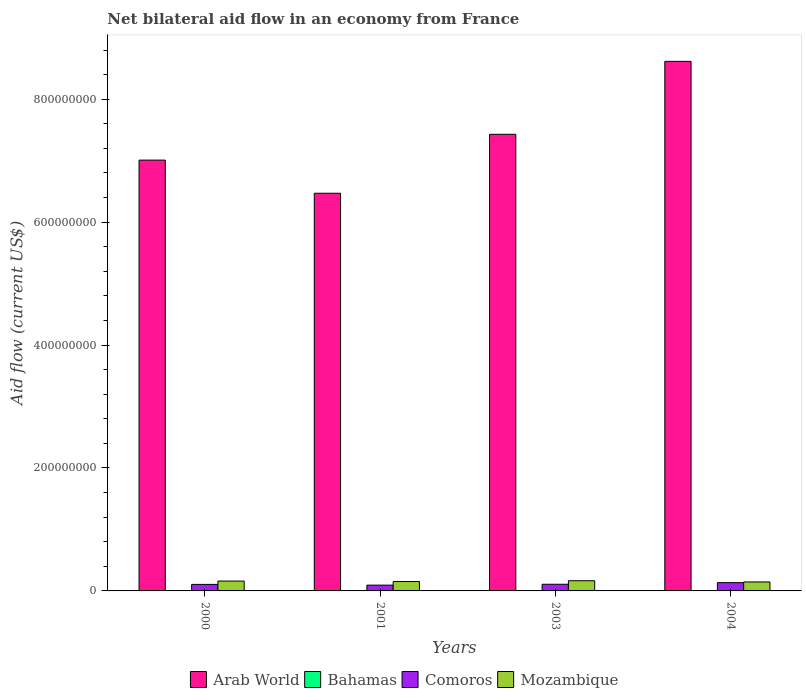How many different coloured bars are there?
Ensure brevity in your answer.  4. How many groups of bars are there?
Make the answer very short. 4. Are the number of bars per tick equal to the number of legend labels?
Offer a very short reply. Yes. Are the number of bars on each tick of the X-axis equal?
Provide a succinct answer. Yes. What is the label of the 2nd group of bars from the left?
Make the answer very short. 2001. What is the net bilateral aid flow in Mozambique in 2003?
Your response must be concise. 1.66e+07. Across all years, what is the maximum net bilateral aid flow in Mozambique?
Ensure brevity in your answer.  1.66e+07. Across all years, what is the minimum net bilateral aid flow in Bahamas?
Give a very brief answer. 10000. In which year was the net bilateral aid flow in Arab World maximum?
Ensure brevity in your answer.  2004. In which year was the net bilateral aid flow in Bahamas minimum?
Provide a succinct answer. 2000. What is the total net bilateral aid flow in Arab World in the graph?
Keep it short and to the point. 2.95e+09. What is the difference between the net bilateral aid flow in Bahamas in 2000 and the net bilateral aid flow in Comoros in 2003?
Your response must be concise. -1.08e+07. What is the average net bilateral aid flow in Bahamas per year?
Make the answer very short. 10000. In the year 2001, what is the difference between the net bilateral aid flow in Arab World and net bilateral aid flow in Mozambique?
Keep it short and to the point. 6.32e+08. What is the ratio of the net bilateral aid flow in Mozambique in 2001 to that in 2003?
Offer a very short reply. 0.92. Is the net bilateral aid flow in Arab World in 2000 less than that in 2004?
Provide a succinct answer. Yes. Is the difference between the net bilateral aid flow in Arab World in 2000 and 2001 greater than the difference between the net bilateral aid flow in Mozambique in 2000 and 2001?
Offer a terse response. Yes. What is the difference between the highest and the second highest net bilateral aid flow in Comoros?
Keep it short and to the point. 2.66e+06. In how many years, is the net bilateral aid flow in Mozambique greater than the average net bilateral aid flow in Mozambique taken over all years?
Your response must be concise. 2. Is the sum of the net bilateral aid flow in Mozambique in 2001 and 2003 greater than the maximum net bilateral aid flow in Comoros across all years?
Your answer should be compact. Yes. Is it the case that in every year, the sum of the net bilateral aid flow in Arab World and net bilateral aid flow in Mozambique is greater than the sum of net bilateral aid flow in Comoros and net bilateral aid flow in Bahamas?
Ensure brevity in your answer.  Yes. What does the 2nd bar from the left in 2001 represents?
Your response must be concise. Bahamas. What does the 1st bar from the right in 2004 represents?
Make the answer very short. Mozambique. How many bars are there?
Your answer should be compact. 16. How many years are there in the graph?
Your response must be concise. 4. What is the difference between two consecutive major ticks on the Y-axis?
Give a very brief answer. 2.00e+08. Are the values on the major ticks of Y-axis written in scientific E-notation?
Ensure brevity in your answer.  No. Does the graph contain any zero values?
Make the answer very short. No. How are the legend labels stacked?
Offer a very short reply. Horizontal. What is the title of the graph?
Keep it short and to the point. Net bilateral aid flow in an economy from France. What is the label or title of the X-axis?
Give a very brief answer. Years. What is the Aid flow (current US$) of Arab World in 2000?
Provide a succinct answer. 7.01e+08. What is the Aid flow (current US$) of Bahamas in 2000?
Your response must be concise. 10000. What is the Aid flow (current US$) in Comoros in 2000?
Provide a succinct answer. 1.06e+07. What is the Aid flow (current US$) in Mozambique in 2000?
Provide a short and direct response. 1.60e+07. What is the Aid flow (current US$) in Arab World in 2001?
Offer a very short reply. 6.47e+08. What is the Aid flow (current US$) in Comoros in 2001?
Give a very brief answer. 9.42e+06. What is the Aid flow (current US$) of Mozambique in 2001?
Offer a very short reply. 1.53e+07. What is the Aid flow (current US$) of Arab World in 2003?
Provide a succinct answer. 7.43e+08. What is the Aid flow (current US$) of Bahamas in 2003?
Offer a very short reply. 10000. What is the Aid flow (current US$) in Comoros in 2003?
Offer a very short reply. 1.08e+07. What is the Aid flow (current US$) of Mozambique in 2003?
Ensure brevity in your answer.  1.66e+07. What is the Aid flow (current US$) of Arab World in 2004?
Your answer should be very brief. 8.62e+08. What is the Aid flow (current US$) of Comoros in 2004?
Your answer should be very brief. 1.35e+07. What is the Aid flow (current US$) of Mozambique in 2004?
Provide a succinct answer. 1.46e+07. Across all years, what is the maximum Aid flow (current US$) of Arab World?
Provide a succinct answer. 8.62e+08. Across all years, what is the maximum Aid flow (current US$) of Comoros?
Your answer should be compact. 1.35e+07. Across all years, what is the maximum Aid flow (current US$) in Mozambique?
Offer a very short reply. 1.66e+07. Across all years, what is the minimum Aid flow (current US$) in Arab World?
Keep it short and to the point. 6.47e+08. Across all years, what is the minimum Aid flow (current US$) of Bahamas?
Your answer should be compact. 10000. Across all years, what is the minimum Aid flow (current US$) in Comoros?
Offer a very short reply. 9.42e+06. Across all years, what is the minimum Aid flow (current US$) of Mozambique?
Your response must be concise. 1.46e+07. What is the total Aid flow (current US$) of Arab World in the graph?
Your response must be concise. 2.95e+09. What is the total Aid flow (current US$) in Comoros in the graph?
Your response must be concise. 4.43e+07. What is the total Aid flow (current US$) in Mozambique in the graph?
Ensure brevity in your answer.  6.26e+07. What is the difference between the Aid flow (current US$) in Arab World in 2000 and that in 2001?
Make the answer very short. 5.39e+07. What is the difference between the Aid flow (current US$) of Comoros in 2000 and that in 2001?
Your response must be concise. 1.18e+06. What is the difference between the Aid flow (current US$) of Mozambique in 2000 and that in 2001?
Ensure brevity in your answer.  7.40e+05. What is the difference between the Aid flow (current US$) of Arab World in 2000 and that in 2003?
Keep it short and to the point. -4.20e+07. What is the difference between the Aid flow (current US$) in Comoros in 2000 and that in 2003?
Give a very brief answer. -2.30e+05. What is the difference between the Aid flow (current US$) of Mozambique in 2000 and that in 2003?
Offer a terse response. -5.40e+05. What is the difference between the Aid flow (current US$) in Arab World in 2000 and that in 2004?
Keep it short and to the point. -1.61e+08. What is the difference between the Aid flow (current US$) of Bahamas in 2000 and that in 2004?
Provide a succinct answer. 0. What is the difference between the Aid flow (current US$) in Comoros in 2000 and that in 2004?
Ensure brevity in your answer.  -2.89e+06. What is the difference between the Aid flow (current US$) in Mozambique in 2000 and that in 2004?
Offer a terse response. 1.44e+06. What is the difference between the Aid flow (current US$) of Arab World in 2001 and that in 2003?
Make the answer very short. -9.59e+07. What is the difference between the Aid flow (current US$) of Bahamas in 2001 and that in 2003?
Make the answer very short. 0. What is the difference between the Aid flow (current US$) in Comoros in 2001 and that in 2003?
Keep it short and to the point. -1.41e+06. What is the difference between the Aid flow (current US$) in Mozambique in 2001 and that in 2003?
Ensure brevity in your answer.  -1.28e+06. What is the difference between the Aid flow (current US$) in Arab World in 2001 and that in 2004?
Offer a terse response. -2.15e+08. What is the difference between the Aid flow (current US$) in Comoros in 2001 and that in 2004?
Your response must be concise. -4.07e+06. What is the difference between the Aid flow (current US$) of Mozambique in 2001 and that in 2004?
Provide a succinct answer. 7.00e+05. What is the difference between the Aid flow (current US$) of Arab World in 2003 and that in 2004?
Provide a succinct answer. -1.19e+08. What is the difference between the Aid flow (current US$) of Comoros in 2003 and that in 2004?
Offer a very short reply. -2.66e+06. What is the difference between the Aid flow (current US$) of Mozambique in 2003 and that in 2004?
Offer a terse response. 1.98e+06. What is the difference between the Aid flow (current US$) in Arab World in 2000 and the Aid flow (current US$) in Bahamas in 2001?
Your response must be concise. 7.01e+08. What is the difference between the Aid flow (current US$) of Arab World in 2000 and the Aid flow (current US$) of Comoros in 2001?
Keep it short and to the point. 6.91e+08. What is the difference between the Aid flow (current US$) in Arab World in 2000 and the Aid flow (current US$) in Mozambique in 2001?
Keep it short and to the point. 6.86e+08. What is the difference between the Aid flow (current US$) of Bahamas in 2000 and the Aid flow (current US$) of Comoros in 2001?
Offer a very short reply. -9.41e+06. What is the difference between the Aid flow (current US$) in Bahamas in 2000 and the Aid flow (current US$) in Mozambique in 2001?
Offer a terse response. -1.53e+07. What is the difference between the Aid flow (current US$) of Comoros in 2000 and the Aid flow (current US$) of Mozambique in 2001?
Give a very brief answer. -4.71e+06. What is the difference between the Aid flow (current US$) of Arab World in 2000 and the Aid flow (current US$) of Bahamas in 2003?
Your response must be concise. 7.01e+08. What is the difference between the Aid flow (current US$) in Arab World in 2000 and the Aid flow (current US$) in Comoros in 2003?
Offer a terse response. 6.90e+08. What is the difference between the Aid flow (current US$) in Arab World in 2000 and the Aid flow (current US$) in Mozambique in 2003?
Your answer should be very brief. 6.84e+08. What is the difference between the Aid flow (current US$) of Bahamas in 2000 and the Aid flow (current US$) of Comoros in 2003?
Make the answer very short. -1.08e+07. What is the difference between the Aid flow (current US$) in Bahamas in 2000 and the Aid flow (current US$) in Mozambique in 2003?
Your answer should be compact. -1.66e+07. What is the difference between the Aid flow (current US$) in Comoros in 2000 and the Aid flow (current US$) in Mozambique in 2003?
Your answer should be compact. -5.99e+06. What is the difference between the Aid flow (current US$) in Arab World in 2000 and the Aid flow (current US$) in Bahamas in 2004?
Keep it short and to the point. 7.01e+08. What is the difference between the Aid flow (current US$) in Arab World in 2000 and the Aid flow (current US$) in Comoros in 2004?
Give a very brief answer. 6.87e+08. What is the difference between the Aid flow (current US$) in Arab World in 2000 and the Aid flow (current US$) in Mozambique in 2004?
Ensure brevity in your answer.  6.86e+08. What is the difference between the Aid flow (current US$) in Bahamas in 2000 and the Aid flow (current US$) in Comoros in 2004?
Your answer should be compact. -1.35e+07. What is the difference between the Aid flow (current US$) in Bahamas in 2000 and the Aid flow (current US$) in Mozambique in 2004?
Provide a succinct answer. -1.46e+07. What is the difference between the Aid flow (current US$) of Comoros in 2000 and the Aid flow (current US$) of Mozambique in 2004?
Your answer should be compact. -4.01e+06. What is the difference between the Aid flow (current US$) in Arab World in 2001 and the Aid flow (current US$) in Bahamas in 2003?
Your answer should be compact. 6.47e+08. What is the difference between the Aid flow (current US$) of Arab World in 2001 and the Aid flow (current US$) of Comoros in 2003?
Offer a terse response. 6.36e+08. What is the difference between the Aid flow (current US$) in Arab World in 2001 and the Aid flow (current US$) in Mozambique in 2003?
Provide a short and direct response. 6.30e+08. What is the difference between the Aid flow (current US$) in Bahamas in 2001 and the Aid flow (current US$) in Comoros in 2003?
Ensure brevity in your answer.  -1.08e+07. What is the difference between the Aid flow (current US$) in Bahamas in 2001 and the Aid flow (current US$) in Mozambique in 2003?
Give a very brief answer. -1.66e+07. What is the difference between the Aid flow (current US$) in Comoros in 2001 and the Aid flow (current US$) in Mozambique in 2003?
Your response must be concise. -7.17e+06. What is the difference between the Aid flow (current US$) of Arab World in 2001 and the Aid flow (current US$) of Bahamas in 2004?
Give a very brief answer. 6.47e+08. What is the difference between the Aid flow (current US$) of Arab World in 2001 and the Aid flow (current US$) of Comoros in 2004?
Offer a very short reply. 6.34e+08. What is the difference between the Aid flow (current US$) of Arab World in 2001 and the Aid flow (current US$) of Mozambique in 2004?
Make the answer very short. 6.32e+08. What is the difference between the Aid flow (current US$) of Bahamas in 2001 and the Aid flow (current US$) of Comoros in 2004?
Your answer should be very brief. -1.35e+07. What is the difference between the Aid flow (current US$) of Bahamas in 2001 and the Aid flow (current US$) of Mozambique in 2004?
Provide a short and direct response. -1.46e+07. What is the difference between the Aid flow (current US$) of Comoros in 2001 and the Aid flow (current US$) of Mozambique in 2004?
Keep it short and to the point. -5.19e+06. What is the difference between the Aid flow (current US$) in Arab World in 2003 and the Aid flow (current US$) in Bahamas in 2004?
Give a very brief answer. 7.43e+08. What is the difference between the Aid flow (current US$) of Arab World in 2003 and the Aid flow (current US$) of Comoros in 2004?
Provide a short and direct response. 7.29e+08. What is the difference between the Aid flow (current US$) in Arab World in 2003 and the Aid flow (current US$) in Mozambique in 2004?
Provide a short and direct response. 7.28e+08. What is the difference between the Aid flow (current US$) in Bahamas in 2003 and the Aid flow (current US$) in Comoros in 2004?
Offer a very short reply. -1.35e+07. What is the difference between the Aid flow (current US$) in Bahamas in 2003 and the Aid flow (current US$) in Mozambique in 2004?
Keep it short and to the point. -1.46e+07. What is the difference between the Aid flow (current US$) of Comoros in 2003 and the Aid flow (current US$) of Mozambique in 2004?
Your answer should be compact. -3.78e+06. What is the average Aid flow (current US$) in Arab World per year?
Provide a succinct answer. 7.38e+08. What is the average Aid flow (current US$) of Comoros per year?
Offer a very short reply. 1.11e+07. What is the average Aid flow (current US$) of Mozambique per year?
Your answer should be very brief. 1.56e+07. In the year 2000, what is the difference between the Aid flow (current US$) of Arab World and Aid flow (current US$) of Bahamas?
Provide a succinct answer. 7.01e+08. In the year 2000, what is the difference between the Aid flow (current US$) of Arab World and Aid flow (current US$) of Comoros?
Give a very brief answer. 6.90e+08. In the year 2000, what is the difference between the Aid flow (current US$) of Arab World and Aid flow (current US$) of Mozambique?
Keep it short and to the point. 6.85e+08. In the year 2000, what is the difference between the Aid flow (current US$) in Bahamas and Aid flow (current US$) in Comoros?
Your answer should be very brief. -1.06e+07. In the year 2000, what is the difference between the Aid flow (current US$) of Bahamas and Aid flow (current US$) of Mozambique?
Provide a succinct answer. -1.60e+07. In the year 2000, what is the difference between the Aid flow (current US$) of Comoros and Aid flow (current US$) of Mozambique?
Provide a succinct answer. -5.45e+06. In the year 2001, what is the difference between the Aid flow (current US$) in Arab World and Aid flow (current US$) in Bahamas?
Keep it short and to the point. 6.47e+08. In the year 2001, what is the difference between the Aid flow (current US$) of Arab World and Aid flow (current US$) of Comoros?
Make the answer very short. 6.38e+08. In the year 2001, what is the difference between the Aid flow (current US$) in Arab World and Aid flow (current US$) in Mozambique?
Your answer should be very brief. 6.32e+08. In the year 2001, what is the difference between the Aid flow (current US$) in Bahamas and Aid flow (current US$) in Comoros?
Your answer should be very brief. -9.41e+06. In the year 2001, what is the difference between the Aid flow (current US$) in Bahamas and Aid flow (current US$) in Mozambique?
Offer a very short reply. -1.53e+07. In the year 2001, what is the difference between the Aid flow (current US$) of Comoros and Aid flow (current US$) of Mozambique?
Offer a very short reply. -5.89e+06. In the year 2003, what is the difference between the Aid flow (current US$) of Arab World and Aid flow (current US$) of Bahamas?
Offer a terse response. 7.43e+08. In the year 2003, what is the difference between the Aid flow (current US$) in Arab World and Aid flow (current US$) in Comoros?
Give a very brief answer. 7.32e+08. In the year 2003, what is the difference between the Aid flow (current US$) of Arab World and Aid flow (current US$) of Mozambique?
Your answer should be very brief. 7.26e+08. In the year 2003, what is the difference between the Aid flow (current US$) in Bahamas and Aid flow (current US$) in Comoros?
Your answer should be very brief. -1.08e+07. In the year 2003, what is the difference between the Aid flow (current US$) of Bahamas and Aid flow (current US$) of Mozambique?
Offer a terse response. -1.66e+07. In the year 2003, what is the difference between the Aid flow (current US$) of Comoros and Aid flow (current US$) of Mozambique?
Make the answer very short. -5.76e+06. In the year 2004, what is the difference between the Aid flow (current US$) in Arab World and Aid flow (current US$) in Bahamas?
Provide a short and direct response. 8.62e+08. In the year 2004, what is the difference between the Aid flow (current US$) in Arab World and Aid flow (current US$) in Comoros?
Keep it short and to the point. 8.48e+08. In the year 2004, what is the difference between the Aid flow (current US$) in Arab World and Aid flow (current US$) in Mozambique?
Give a very brief answer. 8.47e+08. In the year 2004, what is the difference between the Aid flow (current US$) of Bahamas and Aid flow (current US$) of Comoros?
Ensure brevity in your answer.  -1.35e+07. In the year 2004, what is the difference between the Aid flow (current US$) in Bahamas and Aid flow (current US$) in Mozambique?
Provide a short and direct response. -1.46e+07. In the year 2004, what is the difference between the Aid flow (current US$) in Comoros and Aid flow (current US$) in Mozambique?
Provide a short and direct response. -1.12e+06. What is the ratio of the Aid flow (current US$) in Bahamas in 2000 to that in 2001?
Your answer should be very brief. 1. What is the ratio of the Aid flow (current US$) in Comoros in 2000 to that in 2001?
Offer a very short reply. 1.13. What is the ratio of the Aid flow (current US$) of Mozambique in 2000 to that in 2001?
Your answer should be very brief. 1.05. What is the ratio of the Aid flow (current US$) of Arab World in 2000 to that in 2003?
Your answer should be compact. 0.94. What is the ratio of the Aid flow (current US$) of Bahamas in 2000 to that in 2003?
Your response must be concise. 1. What is the ratio of the Aid flow (current US$) in Comoros in 2000 to that in 2003?
Offer a very short reply. 0.98. What is the ratio of the Aid flow (current US$) of Mozambique in 2000 to that in 2003?
Offer a terse response. 0.97. What is the ratio of the Aid flow (current US$) in Arab World in 2000 to that in 2004?
Provide a short and direct response. 0.81. What is the ratio of the Aid flow (current US$) of Bahamas in 2000 to that in 2004?
Your answer should be very brief. 1. What is the ratio of the Aid flow (current US$) in Comoros in 2000 to that in 2004?
Your answer should be compact. 0.79. What is the ratio of the Aid flow (current US$) of Mozambique in 2000 to that in 2004?
Keep it short and to the point. 1.1. What is the ratio of the Aid flow (current US$) in Arab World in 2001 to that in 2003?
Provide a short and direct response. 0.87. What is the ratio of the Aid flow (current US$) in Bahamas in 2001 to that in 2003?
Provide a succinct answer. 1. What is the ratio of the Aid flow (current US$) of Comoros in 2001 to that in 2003?
Provide a short and direct response. 0.87. What is the ratio of the Aid flow (current US$) in Mozambique in 2001 to that in 2003?
Offer a terse response. 0.92. What is the ratio of the Aid flow (current US$) of Arab World in 2001 to that in 2004?
Your answer should be very brief. 0.75. What is the ratio of the Aid flow (current US$) of Comoros in 2001 to that in 2004?
Your response must be concise. 0.7. What is the ratio of the Aid flow (current US$) of Mozambique in 2001 to that in 2004?
Your answer should be very brief. 1.05. What is the ratio of the Aid flow (current US$) in Arab World in 2003 to that in 2004?
Your response must be concise. 0.86. What is the ratio of the Aid flow (current US$) in Bahamas in 2003 to that in 2004?
Provide a succinct answer. 1. What is the ratio of the Aid flow (current US$) in Comoros in 2003 to that in 2004?
Keep it short and to the point. 0.8. What is the ratio of the Aid flow (current US$) of Mozambique in 2003 to that in 2004?
Provide a succinct answer. 1.14. What is the difference between the highest and the second highest Aid flow (current US$) of Arab World?
Give a very brief answer. 1.19e+08. What is the difference between the highest and the second highest Aid flow (current US$) of Bahamas?
Your answer should be very brief. 0. What is the difference between the highest and the second highest Aid flow (current US$) in Comoros?
Offer a terse response. 2.66e+06. What is the difference between the highest and the second highest Aid flow (current US$) in Mozambique?
Your answer should be compact. 5.40e+05. What is the difference between the highest and the lowest Aid flow (current US$) of Arab World?
Make the answer very short. 2.15e+08. What is the difference between the highest and the lowest Aid flow (current US$) of Bahamas?
Your answer should be very brief. 0. What is the difference between the highest and the lowest Aid flow (current US$) of Comoros?
Make the answer very short. 4.07e+06. What is the difference between the highest and the lowest Aid flow (current US$) of Mozambique?
Your answer should be compact. 1.98e+06. 